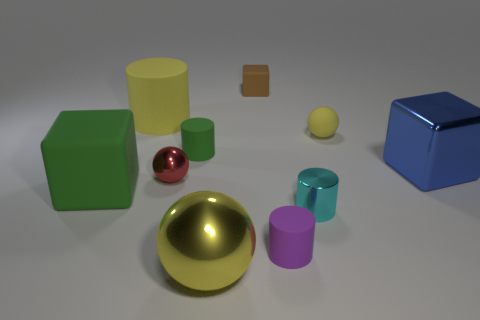How many big brown cubes have the same material as the green cylinder?
Offer a very short reply. 0. How many other things are the same size as the green rubber cylinder?
Your answer should be compact. 5. Are there any rubber objects of the same size as the yellow rubber cylinder?
Give a very brief answer. Yes. Is the color of the tiny sphere that is in front of the tiny yellow sphere the same as the large sphere?
Keep it short and to the point. No. How many objects are either small cylinders or tiny matte things?
Offer a very short reply. 5. There is a block behind the blue cube; does it have the same size as the big cylinder?
Provide a succinct answer. No. What is the size of the rubber thing that is both to the left of the small yellow matte ball and to the right of the brown rubber object?
Offer a terse response. Small. What number of other things are there of the same shape as the yellow shiny object?
Your response must be concise. 2. How many other objects are there of the same material as the small red sphere?
Ensure brevity in your answer.  3. What size is the other rubber object that is the same shape as the large green object?
Offer a very short reply. Small. 